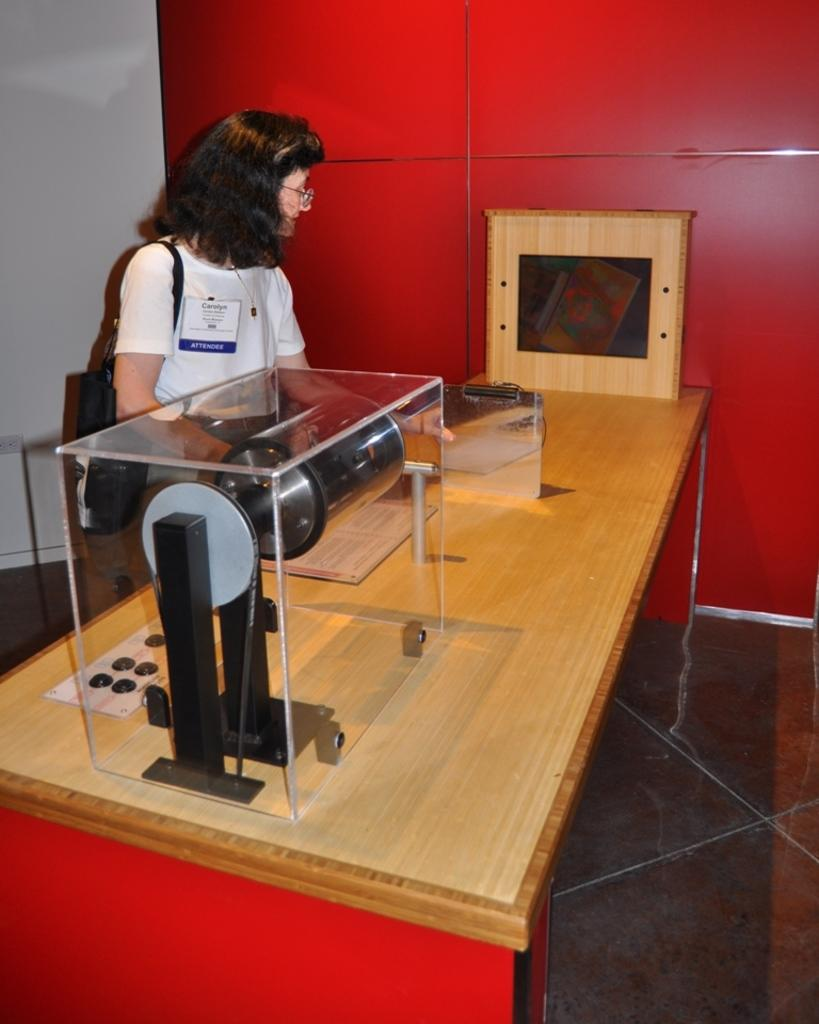What is the gender of the person in the image? The person in the image is a woman. What is the woman doing in the image? The woman is standing. What is the woman wearing in the image? The woman is wearing a bag. What is present on the table in the image? There is a machine on the table. What type of box is visible on the sidewalk in the image? There is no box or sidewalk present in the image. 